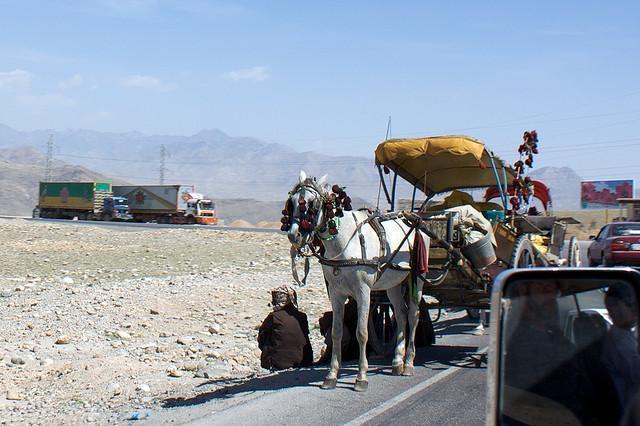In which continent is this road located?
Indicate the correct choice and explain in the format: 'Answer: answer
Rationale: rationale.'
Options: Europe, eastern asia, africa, western asia. Answer: western asia.
Rationale: The landscape, and the decorations on the horses are comparable to those found in western asia. 